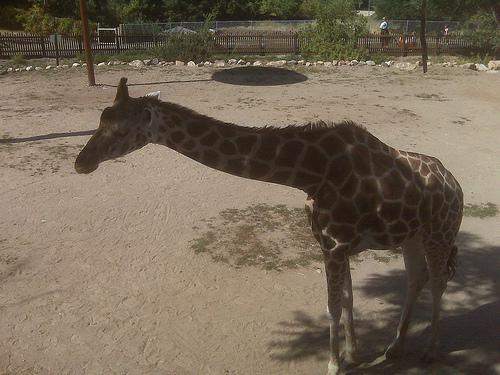Question: what animal is there?
Choices:
A. A horse.
B. Giraffe.
C. A goat.
D. A zebra.
Answer with the letter. Answer: B Question: what is on the ground?
Choices:
A. Snow.
B. Dirt.
C. Grass.
D. Water.
Answer with the letter. Answer: B Question: what color is the dirt?
Choices:
A. Red.
B. Brown.
C. Tan.
D. Grey.
Answer with the letter. Answer: C 